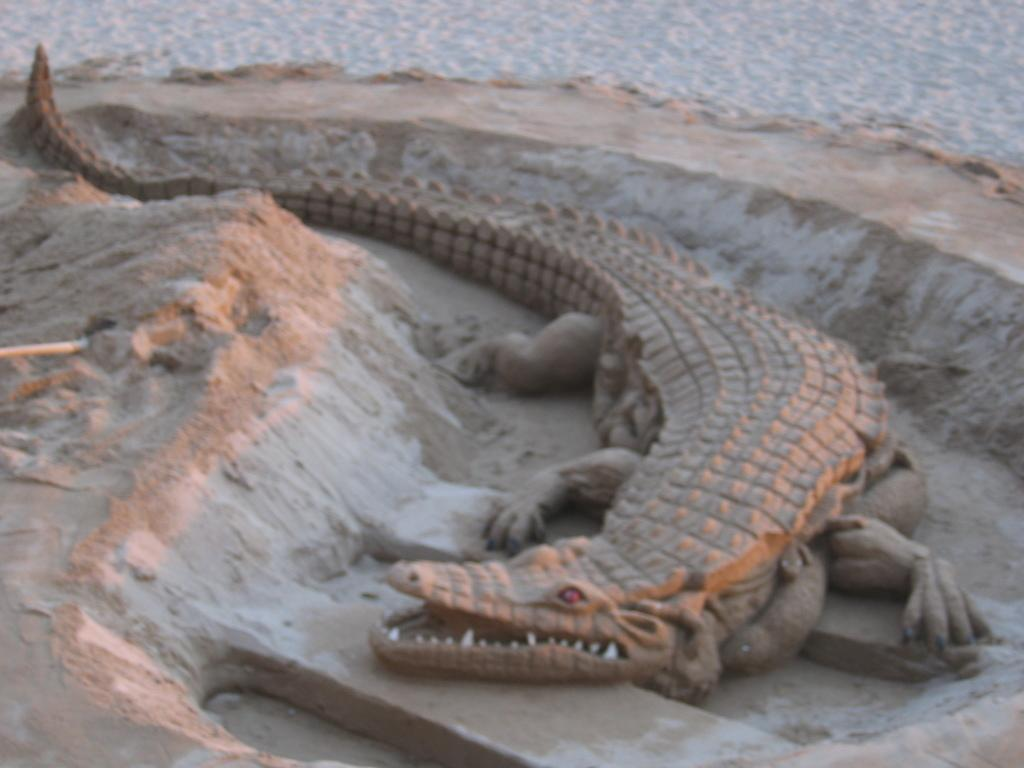What is the main subject in the center of the image? There is a crocodile in the center of the image. What type of terrain is visible at the bottom of the image? There is sand at the bottom of the image. Can you describe the background of the image? There is sand visible in the background of the image. What type of liquid can be seen boiling on the stove in the image? There is no stove or liquid present in the image; it features a crocodile and sand. 